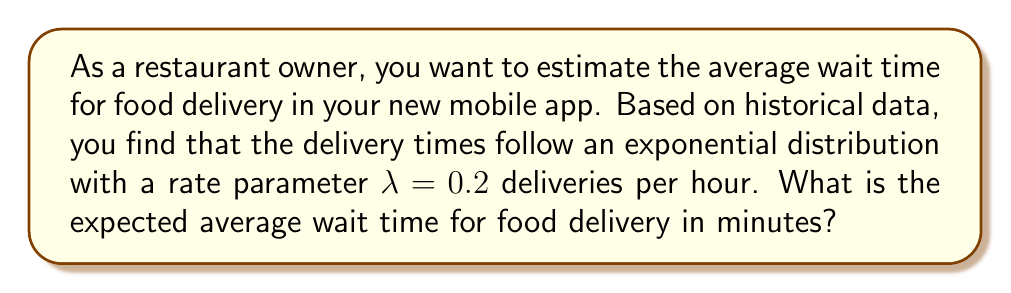What is the answer to this math problem? Let's approach this step-by-step:

1) The exponential distribution is often used to model waiting times. Its probability density function is given by:

   $$f(x) = λe^{-λx}$$

   where λ is the rate parameter.

2) For an exponential distribution, the expected value (mean) is given by:

   $$E(X) = \frac{1}{λ}$$

3) We're given that λ = 0.2 deliveries per hour. Let's substitute this into our formula:

   $$E(X) = \frac{1}{0.2} = 5$$

4) This gives us the expected wait time in hours. To convert to minutes, we multiply by 60:

   $$5 \text{ hours} \times 60 \text{ minutes/hour} = 300 \text{ minutes}$$

Therefore, the expected average wait time for food delivery is 300 minutes.
Answer: 300 minutes 